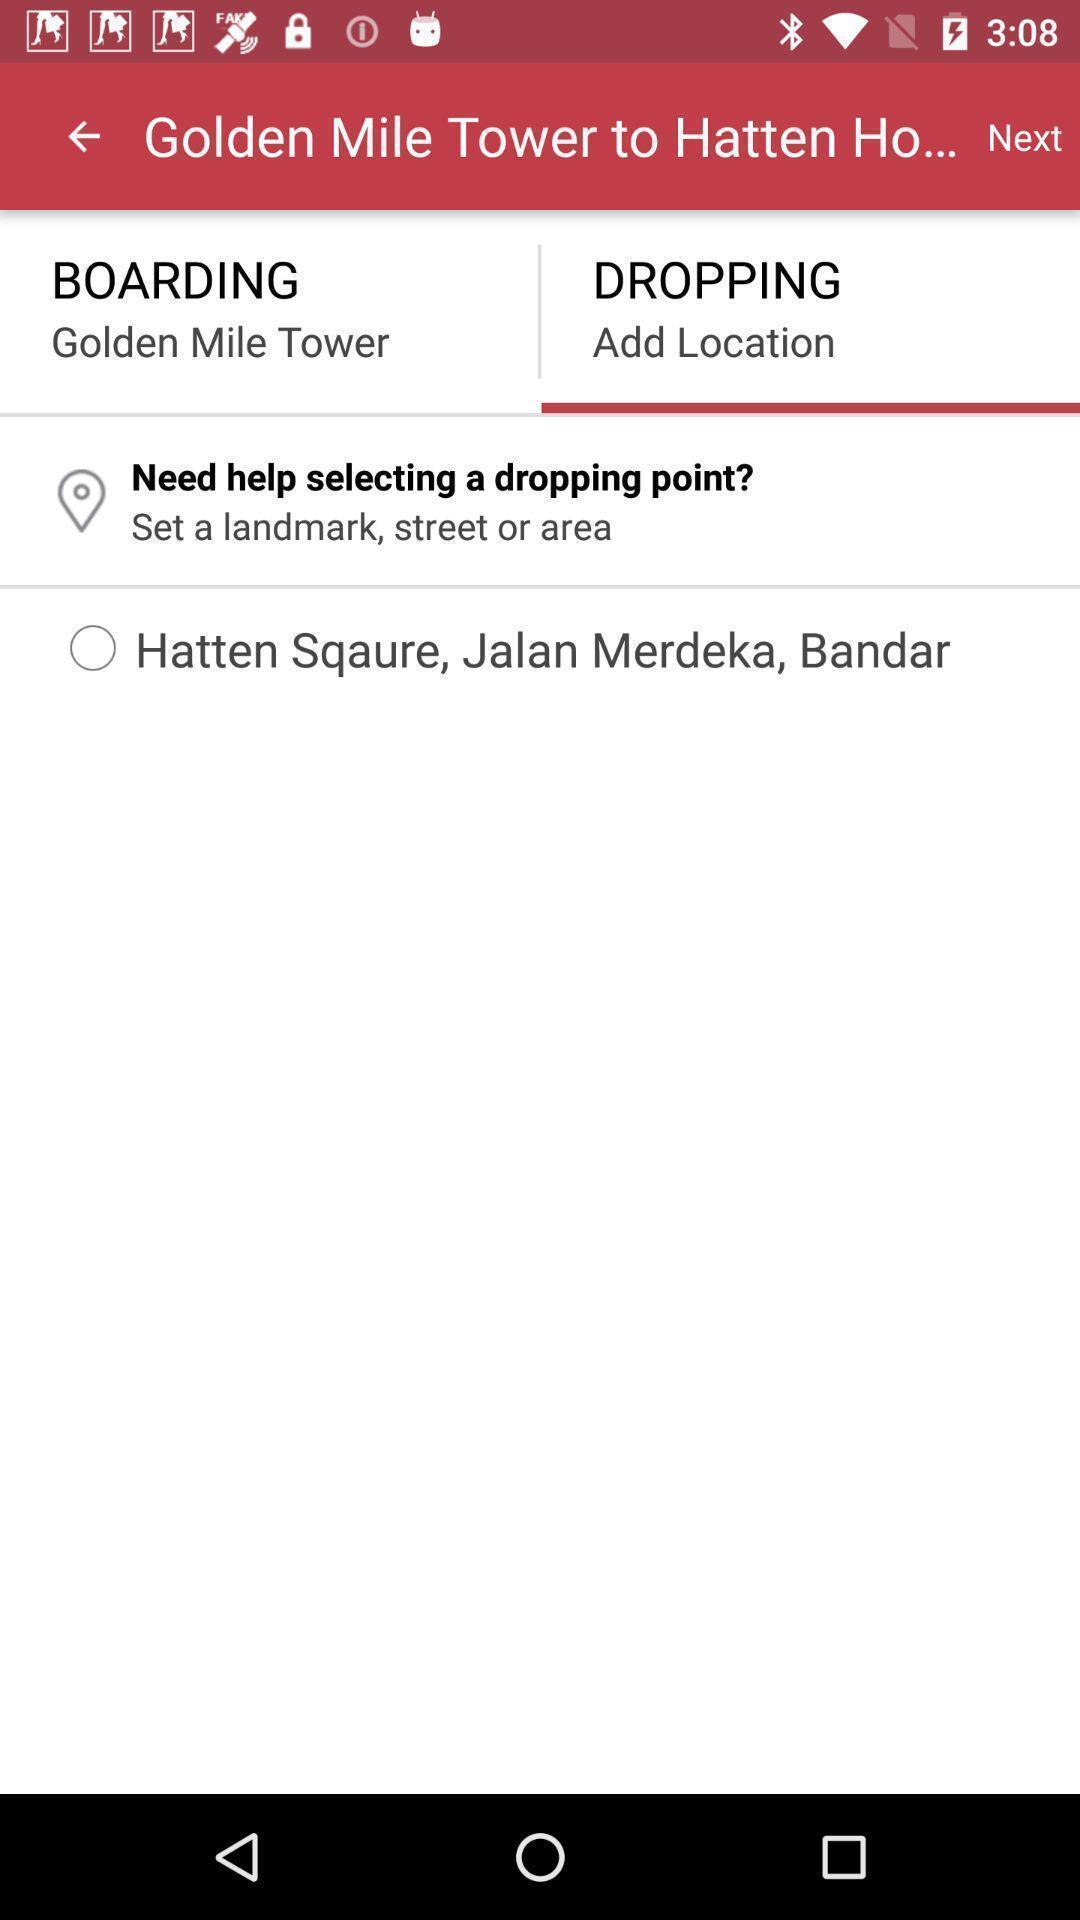What details can you identify in this image? Screen shows dropping details page in travel application. 